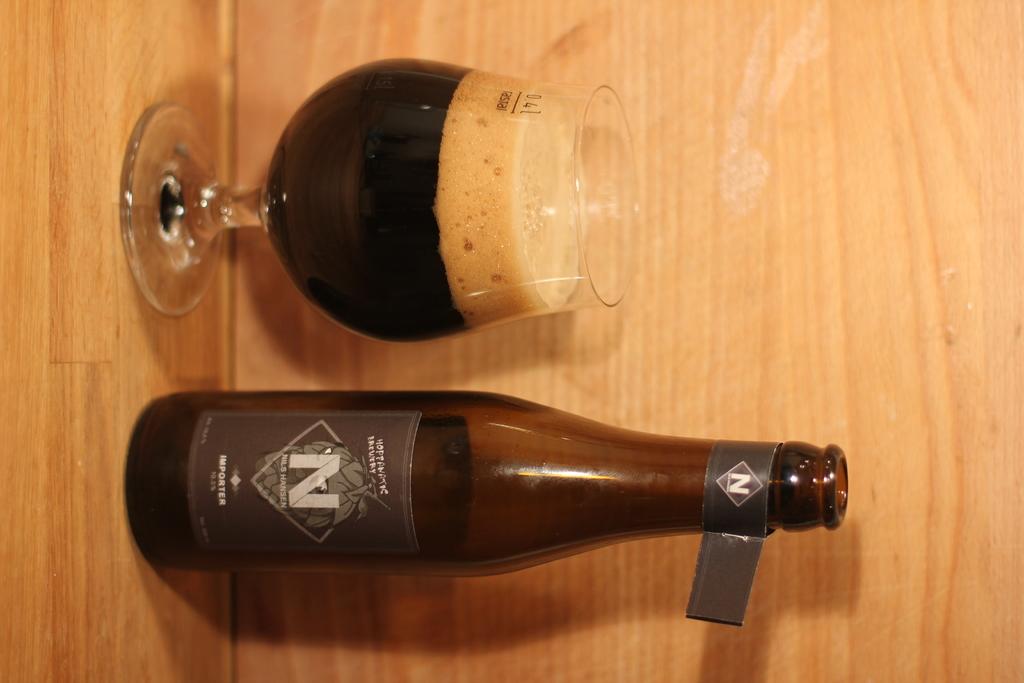What letter is predominant on the bottle?
Keep it short and to the point. N. What brand is this beer?
Your response must be concise. Unanswerable. 